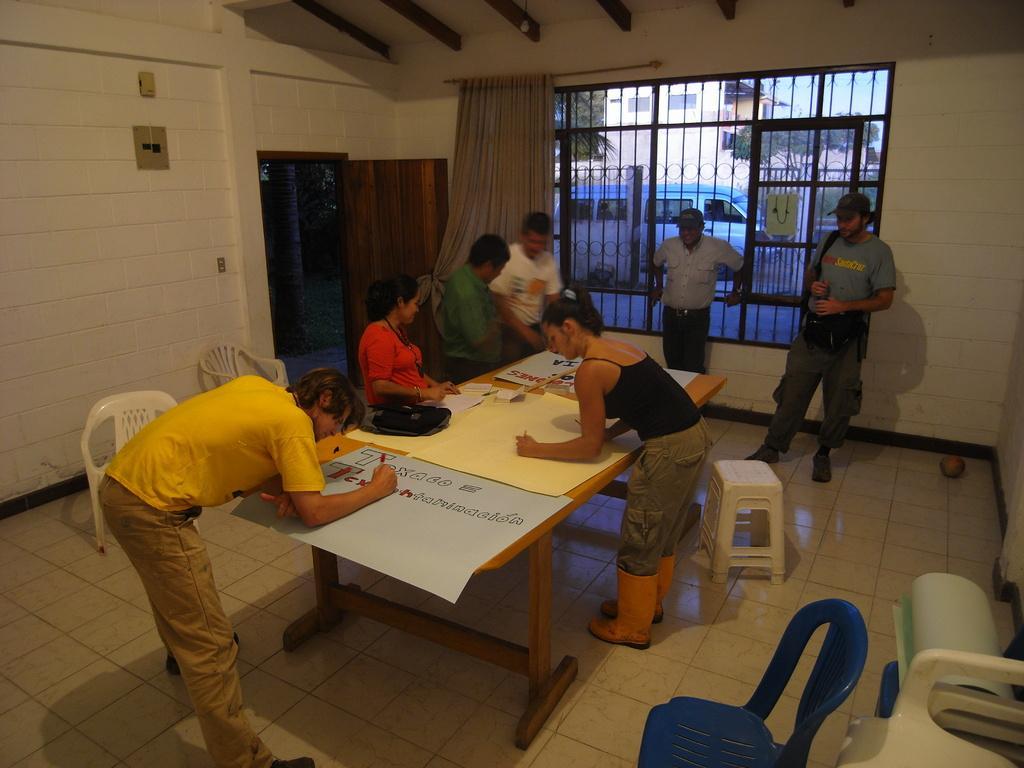Describe this image in one or two sentences. In this image I can see number of people were few of them writing on a chart paper. This image is a view of a room where I can see number of chairs and stools. Outside the window I can see a vehicle, trees and a building. 